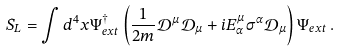<formula> <loc_0><loc_0><loc_500><loc_500>S _ { L } = \int d ^ { 4 } x \Psi _ { e x t } ^ { \dagger } \left ( \frac { 1 } { 2 m } \mathcal { D } ^ { \mu } \mathcal { D } _ { \mu } + i E _ { \alpha } ^ { \mu } \sigma ^ { \alpha } \mathcal { D } _ { \mu } \right ) \Psi _ { e x t } \, .</formula> 